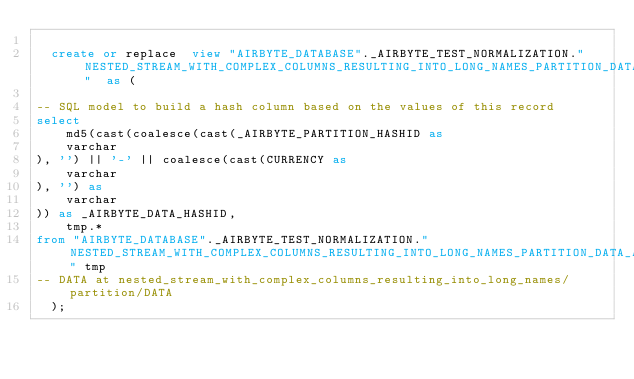Convert code to text. <code><loc_0><loc_0><loc_500><loc_500><_SQL_>
  create or replace  view "AIRBYTE_DATABASE"._AIRBYTE_TEST_NORMALIZATION."NESTED_STREAM_WITH_COMPLEX_COLUMNS_RESULTING_INTO_LONG_NAMES_PARTITION_DATA_AB3"  as (
    
-- SQL model to build a hash column based on the values of this record
select
    md5(cast(coalesce(cast(_AIRBYTE_PARTITION_HASHID as 
    varchar
), '') || '-' || coalesce(cast(CURRENCY as 
    varchar
), '') as 
    varchar
)) as _AIRBYTE_DATA_HASHID,
    tmp.*
from "AIRBYTE_DATABASE"._AIRBYTE_TEST_NORMALIZATION."NESTED_STREAM_WITH_COMPLEX_COLUMNS_RESULTING_INTO_LONG_NAMES_PARTITION_DATA_AB2" tmp
-- DATA at nested_stream_with_complex_columns_resulting_into_long_names/partition/DATA
  );
</code> 